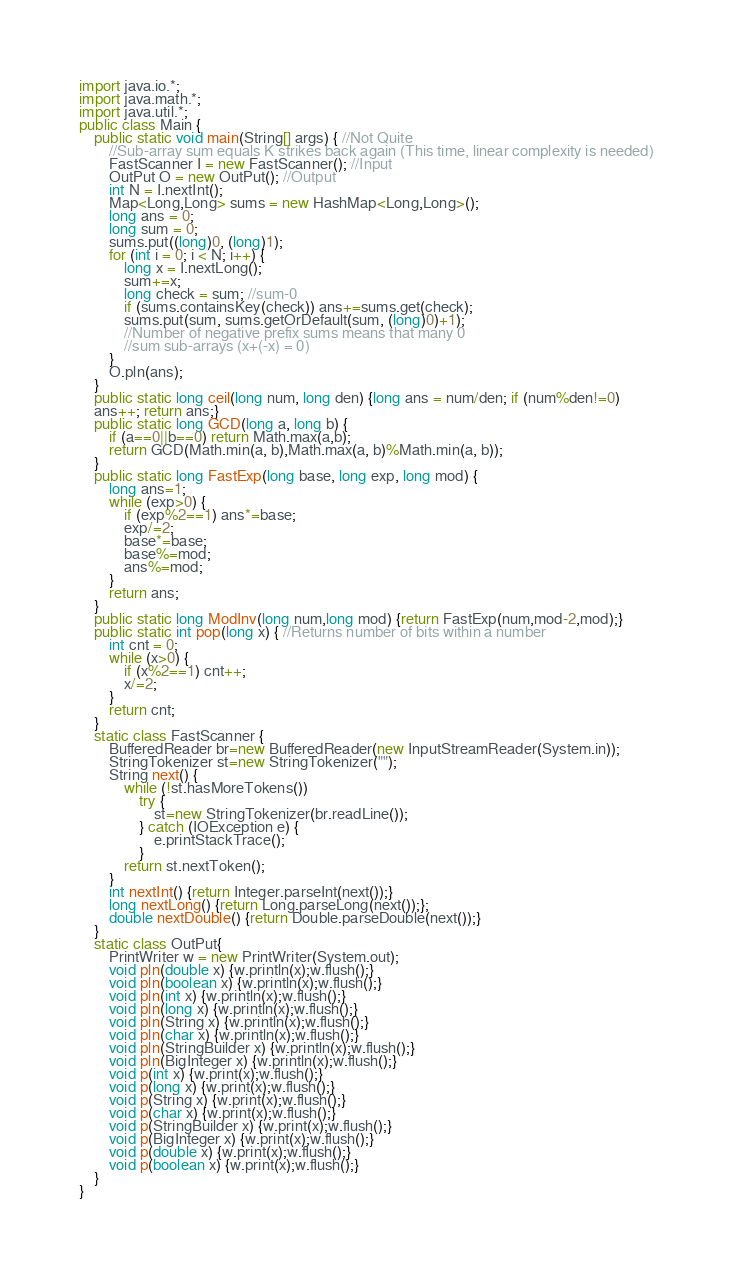<code> <loc_0><loc_0><loc_500><loc_500><_Java_>import java.io.*;
import java.math.*;
import java.util.*;
public class Main {  
	public static void main(String[] args) { //Not Quite
		//Sub-array sum equals K strikes back again (This time, linear complexity is needed)
		FastScanner I = new FastScanner(); //Input
		OutPut O = new OutPut(); //Output
		int N = I.nextInt();
		Map<Long,Long> sums = new HashMap<Long,Long>();
		long ans = 0;
		long sum = 0;
		sums.put((long)0, (long)1);
		for (int i = 0; i < N; i++) {
			long x = I.nextLong();
			sum+=x;
			long check = sum; //sum-0
			if (sums.containsKey(check)) ans+=sums.get(check); 
			sums.put(sum, sums.getOrDefault(sum, (long)0)+1);
			//Number of negative prefix sums means that many 0 
			//sum sub-arrays (x+(-x) = 0)
		}
		O.pln(ans);
	}
	public static long ceil(long num, long den) {long ans = num/den; if (num%den!=0) 
	ans++; return ans;}
	public static long GCD(long a, long b) {
		if (a==0||b==0) return Math.max(a,b);
		return GCD(Math.min(a, b),Math.max(a, b)%Math.min(a, b));
	}
	public static long FastExp(long base, long exp, long mod) {
		long ans=1;
		while (exp>0) {
			if (exp%2==1) ans*=base;
			exp/=2;
			base*=base;
			base%=mod;
			ans%=mod;
		}
		return ans;
	}
	public static long ModInv(long num,long mod) {return FastExp(num,mod-2,mod);}
	public static int pop(long x) { //Returns number of bits within a number
		int cnt = 0;
		while (x>0) {
			if (x%2==1) cnt++;
			x/=2;
		}
		return cnt;
	}
	static class FastScanner {
		BufferedReader br=new BufferedReader(new InputStreamReader(System.in));
		StringTokenizer st=new StringTokenizer("");
		String next() {
			while (!st.hasMoreTokens())
				try {
					st=new StringTokenizer(br.readLine());
				} catch (IOException e) {
					e.printStackTrace();
				}
			return st.nextToken();
		}
		int nextInt() {return Integer.parseInt(next());}
		long nextLong() {return Long.parseLong(next());};
		double nextDouble() {return Double.parseDouble(next());}
	}
	static class OutPut{
		PrintWriter w = new PrintWriter(System.out);
		void pln(double x) {w.println(x);w.flush();}
		void pln(boolean x) {w.println(x);w.flush();}
		void pln(int x) {w.println(x);w.flush();}
		void pln(long x) {w.println(x);w.flush();}
		void pln(String x) {w.println(x);w.flush();}
		void pln(char x) {w.println(x);w.flush();}
		void pln(StringBuilder x) {w.println(x);w.flush();}
		void pln(BigInteger x) {w.println(x);w.flush();}
		void p(int x) {w.print(x);w.flush();}
		void p(long x) {w.print(x);w.flush();}
		void p(String x) {w.print(x);w.flush();}
		void p(char x) {w.print(x);w.flush();}
		void p(StringBuilder x) {w.print(x);w.flush();}
		void p(BigInteger x) {w.print(x);w.flush();}
		void p(double x) {w.print(x);w.flush();}
		void p(boolean x) {w.print(x);w.flush();}
	}
}
</code> 